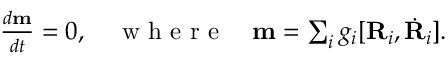Convert formula to latex. <formula><loc_0><loc_0><loc_500><loc_500>\begin{array} { r } { \frac { d { m } } { d t } = 0 , \quad w h e r e \quad m = \sum _ { i } g _ { i } [ { R } _ { i } , \dot { R } _ { i } ] . } \end{array}</formula> 